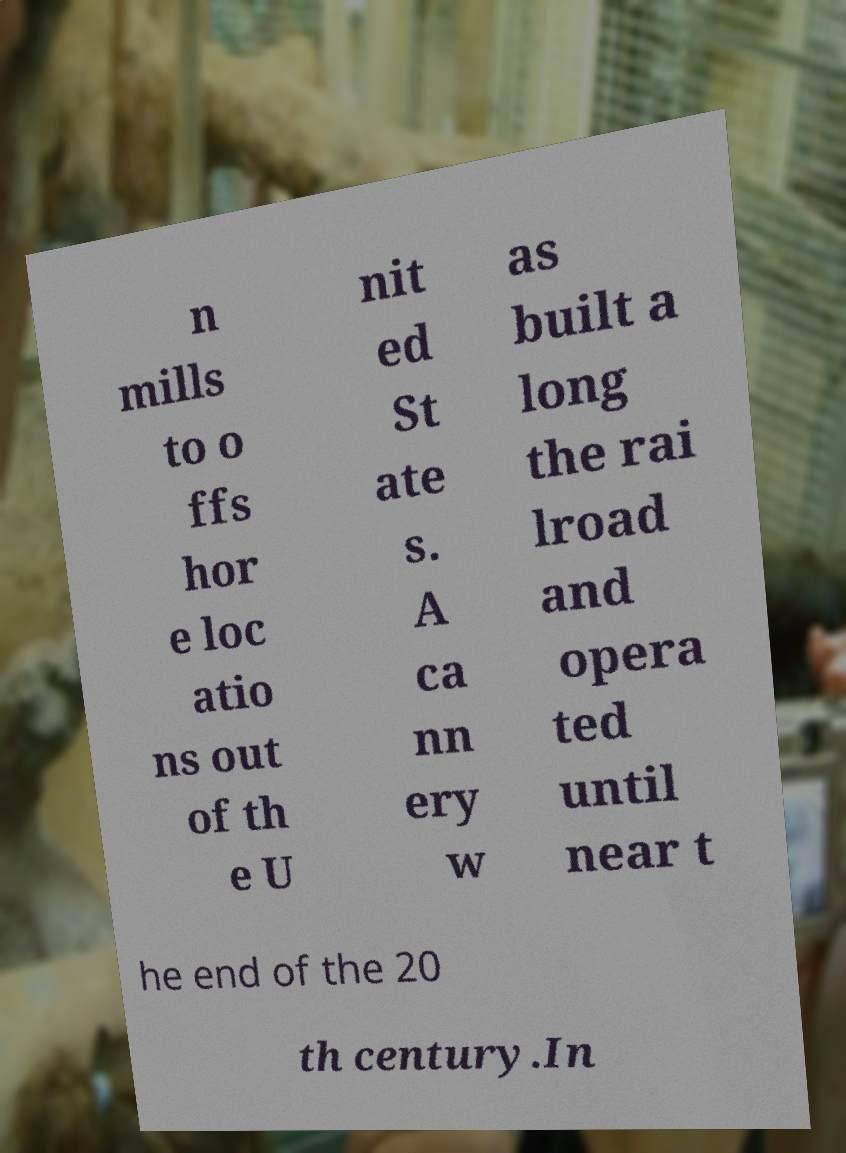There's text embedded in this image that I need extracted. Can you transcribe it verbatim? n mills to o ffs hor e loc atio ns out of th e U nit ed St ate s. A ca nn ery w as built a long the rai lroad and opera ted until near t he end of the 20 th century.In 